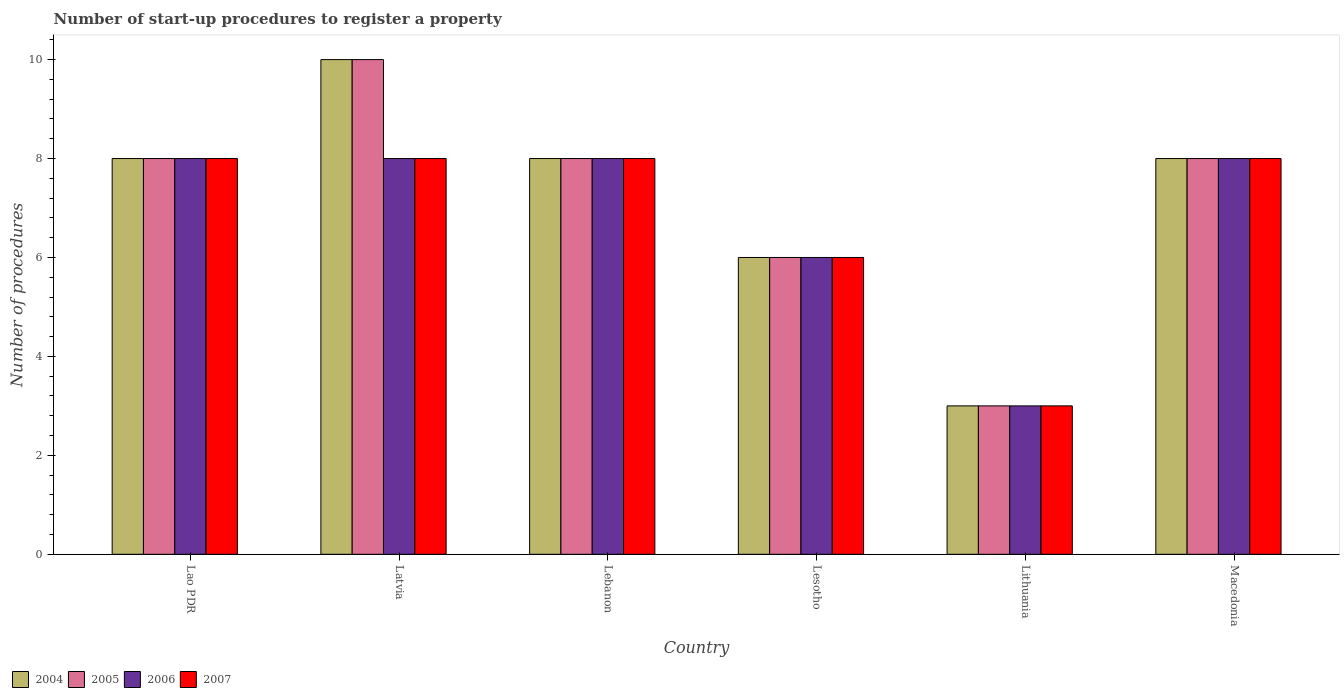How many different coloured bars are there?
Ensure brevity in your answer.  4. Are the number of bars on each tick of the X-axis equal?
Ensure brevity in your answer.  Yes. How many bars are there on the 6th tick from the right?
Your answer should be very brief. 4. What is the label of the 4th group of bars from the left?
Provide a short and direct response. Lesotho. In how many cases, is the number of bars for a given country not equal to the number of legend labels?
Provide a short and direct response. 0. What is the number of procedures required to register a property in 2007 in Lesotho?
Ensure brevity in your answer.  6. In which country was the number of procedures required to register a property in 2006 maximum?
Offer a terse response. Lao PDR. In which country was the number of procedures required to register a property in 2005 minimum?
Offer a very short reply. Lithuania. What is the total number of procedures required to register a property in 2005 in the graph?
Your answer should be very brief. 43. What is the difference between the number of procedures required to register a property in 2006 in Lao PDR and that in Latvia?
Make the answer very short. 0. What is the average number of procedures required to register a property in 2007 per country?
Provide a short and direct response. 6.83. In how many countries, is the number of procedures required to register a property in 2007 greater than 4.8?
Your response must be concise. 5. What is the ratio of the number of procedures required to register a property in 2004 in Lao PDR to that in Lebanon?
Make the answer very short. 1. Is the number of procedures required to register a property in 2007 in Lao PDR less than that in Lesotho?
Provide a short and direct response. No. Is the difference between the number of procedures required to register a property in 2004 in Lesotho and Macedonia greater than the difference between the number of procedures required to register a property in 2006 in Lesotho and Macedonia?
Give a very brief answer. No. What is the difference between the highest and the lowest number of procedures required to register a property in 2005?
Offer a very short reply. 7. Is it the case that in every country, the sum of the number of procedures required to register a property in 2005 and number of procedures required to register a property in 2006 is greater than the sum of number of procedures required to register a property in 2007 and number of procedures required to register a property in 2004?
Your answer should be very brief. No. Is it the case that in every country, the sum of the number of procedures required to register a property in 2005 and number of procedures required to register a property in 2007 is greater than the number of procedures required to register a property in 2004?
Provide a short and direct response. Yes. How many bars are there?
Your answer should be very brief. 24. Are the values on the major ticks of Y-axis written in scientific E-notation?
Offer a very short reply. No. Where does the legend appear in the graph?
Give a very brief answer. Bottom left. What is the title of the graph?
Offer a very short reply. Number of start-up procedures to register a property. Does "2002" appear as one of the legend labels in the graph?
Ensure brevity in your answer.  No. What is the label or title of the Y-axis?
Your response must be concise. Number of procedures. What is the Number of procedures of 2004 in Lao PDR?
Provide a succinct answer. 8. What is the Number of procedures of 2004 in Latvia?
Your answer should be very brief. 10. What is the Number of procedures in 2005 in Latvia?
Ensure brevity in your answer.  10. What is the Number of procedures in 2006 in Lesotho?
Your answer should be compact. 6. What is the Number of procedures of 2007 in Lesotho?
Your response must be concise. 6. What is the Number of procedures in 2004 in Lithuania?
Ensure brevity in your answer.  3. What is the Number of procedures in 2005 in Lithuania?
Your answer should be compact. 3. What is the Number of procedures of 2006 in Lithuania?
Offer a terse response. 3. What is the Number of procedures in 2006 in Macedonia?
Your answer should be compact. 8. Across all countries, what is the maximum Number of procedures of 2004?
Provide a short and direct response. 10. Across all countries, what is the maximum Number of procedures of 2005?
Make the answer very short. 10. Across all countries, what is the minimum Number of procedures of 2005?
Your answer should be compact. 3. Across all countries, what is the minimum Number of procedures in 2006?
Offer a very short reply. 3. Across all countries, what is the minimum Number of procedures of 2007?
Your answer should be very brief. 3. What is the total Number of procedures in 2004 in the graph?
Make the answer very short. 43. What is the total Number of procedures of 2006 in the graph?
Ensure brevity in your answer.  41. What is the total Number of procedures of 2007 in the graph?
Your response must be concise. 41. What is the difference between the Number of procedures of 2004 in Lao PDR and that in Latvia?
Offer a very short reply. -2. What is the difference between the Number of procedures of 2007 in Lao PDR and that in Latvia?
Offer a very short reply. 0. What is the difference between the Number of procedures of 2004 in Lao PDR and that in Lebanon?
Your response must be concise. 0. What is the difference between the Number of procedures of 2006 in Lao PDR and that in Lebanon?
Make the answer very short. 0. What is the difference between the Number of procedures in 2004 in Lao PDR and that in Lesotho?
Give a very brief answer. 2. What is the difference between the Number of procedures in 2005 in Lao PDR and that in Lesotho?
Your answer should be compact. 2. What is the difference between the Number of procedures in 2006 in Lao PDR and that in Lesotho?
Make the answer very short. 2. What is the difference between the Number of procedures of 2007 in Lao PDR and that in Lesotho?
Give a very brief answer. 2. What is the difference between the Number of procedures of 2005 in Lao PDR and that in Lithuania?
Provide a succinct answer. 5. What is the difference between the Number of procedures in 2007 in Lao PDR and that in Lithuania?
Your response must be concise. 5. What is the difference between the Number of procedures in 2005 in Lao PDR and that in Macedonia?
Provide a succinct answer. 0. What is the difference between the Number of procedures of 2006 in Lao PDR and that in Macedonia?
Ensure brevity in your answer.  0. What is the difference between the Number of procedures of 2004 in Latvia and that in Lebanon?
Provide a succinct answer. 2. What is the difference between the Number of procedures in 2005 in Latvia and that in Lesotho?
Your answer should be very brief. 4. What is the difference between the Number of procedures of 2006 in Latvia and that in Lesotho?
Your response must be concise. 2. What is the difference between the Number of procedures of 2007 in Latvia and that in Lesotho?
Provide a succinct answer. 2. What is the difference between the Number of procedures of 2006 in Latvia and that in Lithuania?
Your answer should be very brief. 5. What is the difference between the Number of procedures in 2006 in Latvia and that in Macedonia?
Ensure brevity in your answer.  0. What is the difference between the Number of procedures in 2007 in Latvia and that in Macedonia?
Offer a very short reply. 0. What is the difference between the Number of procedures in 2004 in Lebanon and that in Lesotho?
Ensure brevity in your answer.  2. What is the difference between the Number of procedures of 2005 in Lebanon and that in Lesotho?
Provide a short and direct response. 2. What is the difference between the Number of procedures of 2006 in Lebanon and that in Lesotho?
Your response must be concise. 2. What is the difference between the Number of procedures in 2004 in Lebanon and that in Lithuania?
Your answer should be compact. 5. What is the difference between the Number of procedures of 2005 in Lebanon and that in Lithuania?
Offer a terse response. 5. What is the difference between the Number of procedures of 2006 in Lebanon and that in Lithuania?
Your response must be concise. 5. What is the difference between the Number of procedures of 2006 in Lebanon and that in Macedonia?
Provide a short and direct response. 0. What is the difference between the Number of procedures in 2004 in Lesotho and that in Lithuania?
Make the answer very short. 3. What is the difference between the Number of procedures of 2005 in Lesotho and that in Lithuania?
Your response must be concise. 3. What is the difference between the Number of procedures of 2006 in Lesotho and that in Lithuania?
Make the answer very short. 3. What is the difference between the Number of procedures in 2007 in Lesotho and that in Lithuania?
Give a very brief answer. 3. What is the difference between the Number of procedures in 2005 in Lesotho and that in Macedonia?
Ensure brevity in your answer.  -2. What is the difference between the Number of procedures of 2006 in Lesotho and that in Macedonia?
Offer a terse response. -2. What is the difference between the Number of procedures of 2004 in Lithuania and that in Macedonia?
Offer a terse response. -5. What is the difference between the Number of procedures in 2004 in Lao PDR and the Number of procedures in 2006 in Latvia?
Provide a short and direct response. 0. What is the difference between the Number of procedures in 2005 in Lao PDR and the Number of procedures in 2007 in Latvia?
Provide a succinct answer. 0. What is the difference between the Number of procedures in 2006 in Lao PDR and the Number of procedures in 2007 in Latvia?
Give a very brief answer. 0. What is the difference between the Number of procedures of 2004 in Lao PDR and the Number of procedures of 2005 in Lebanon?
Your response must be concise. 0. What is the difference between the Number of procedures of 2004 in Lao PDR and the Number of procedures of 2007 in Lebanon?
Your answer should be very brief. 0. What is the difference between the Number of procedures in 2005 in Lao PDR and the Number of procedures in 2006 in Lebanon?
Keep it short and to the point. 0. What is the difference between the Number of procedures in 2004 in Lao PDR and the Number of procedures in 2005 in Lesotho?
Offer a terse response. 2. What is the difference between the Number of procedures in 2004 in Lao PDR and the Number of procedures in 2007 in Lesotho?
Ensure brevity in your answer.  2. What is the difference between the Number of procedures in 2005 in Lao PDR and the Number of procedures in 2006 in Lesotho?
Provide a short and direct response. 2. What is the difference between the Number of procedures in 2006 in Lao PDR and the Number of procedures in 2007 in Lesotho?
Keep it short and to the point. 2. What is the difference between the Number of procedures of 2004 in Lao PDR and the Number of procedures of 2007 in Lithuania?
Provide a short and direct response. 5. What is the difference between the Number of procedures in 2005 in Lao PDR and the Number of procedures in 2006 in Lithuania?
Make the answer very short. 5. What is the difference between the Number of procedures of 2006 in Lao PDR and the Number of procedures of 2007 in Lithuania?
Ensure brevity in your answer.  5. What is the difference between the Number of procedures of 2004 in Lao PDR and the Number of procedures of 2006 in Macedonia?
Your response must be concise. 0. What is the difference between the Number of procedures of 2005 in Lao PDR and the Number of procedures of 2006 in Macedonia?
Give a very brief answer. 0. What is the difference between the Number of procedures of 2004 in Latvia and the Number of procedures of 2005 in Lebanon?
Offer a terse response. 2. What is the difference between the Number of procedures of 2005 in Latvia and the Number of procedures of 2006 in Lebanon?
Offer a very short reply. 2. What is the difference between the Number of procedures of 2005 in Latvia and the Number of procedures of 2007 in Lesotho?
Your answer should be compact. 4. What is the difference between the Number of procedures in 2004 in Latvia and the Number of procedures in 2005 in Lithuania?
Give a very brief answer. 7. What is the difference between the Number of procedures in 2004 in Latvia and the Number of procedures in 2006 in Lithuania?
Your answer should be very brief. 7. What is the difference between the Number of procedures in 2004 in Latvia and the Number of procedures in 2007 in Lithuania?
Offer a very short reply. 7. What is the difference between the Number of procedures in 2005 in Latvia and the Number of procedures in 2006 in Lithuania?
Your response must be concise. 7. What is the difference between the Number of procedures of 2004 in Latvia and the Number of procedures of 2005 in Macedonia?
Your answer should be very brief. 2. What is the difference between the Number of procedures in 2004 in Latvia and the Number of procedures in 2007 in Macedonia?
Your answer should be compact. 2. What is the difference between the Number of procedures of 2004 in Lebanon and the Number of procedures of 2005 in Lesotho?
Make the answer very short. 2. What is the difference between the Number of procedures of 2005 in Lebanon and the Number of procedures of 2006 in Lesotho?
Ensure brevity in your answer.  2. What is the difference between the Number of procedures in 2005 in Lebanon and the Number of procedures in 2007 in Lesotho?
Your answer should be compact. 2. What is the difference between the Number of procedures in 2004 in Lebanon and the Number of procedures in 2005 in Lithuania?
Ensure brevity in your answer.  5. What is the difference between the Number of procedures in 2004 in Lebanon and the Number of procedures in 2007 in Lithuania?
Make the answer very short. 5. What is the difference between the Number of procedures in 2004 in Lebanon and the Number of procedures in 2005 in Macedonia?
Provide a short and direct response. 0. What is the difference between the Number of procedures of 2004 in Lebanon and the Number of procedures of 2006 in Macedonia?
Ensure brevity in your answer.  0. What is the difference between the Number of procedures in 2004 in Lebanon and the Number of procedures in 2007 in Macedonia?
Provide a succinct answer. 0. What is the difference between the Number of procedures in 2005 in Lebanon and the Number of procedures in 2006 in Macedonia?
Provide a short and direct response. 0. What is the difference between the Number of procedures of 2004 in Lesotho and the Number of procedures of 2007 in Lithuania?
Ensure brevity in your answer.  3. What is the difference between the Number of procedures in 2005 in Lesotho and the Number of procedures in 2007 in Lithuania?
Provide a short and direct response. 3. What is the difference between the Number of procedures in 2006 in Lesotho and the Number of procedures in 2007 in Lithuania?
Make the answer very short. 3. What is the difference between the Number of procedures of 2004 in Lesotho and the Number of procedures of 2007 in Macedonia?
Your answer should be compact. -2. What is the average Number of procedures of 2004 per country?
Provide a succinct answer. 7.17. What is the average Number of procedures in 2005 per country?
Your answer should be compact. 7.17. What is the average Number of procedures in 2006 per country?
Provide a short and direct response. 6.83. What is the average Number of procedures of 2007 per country?
Offer a very short reply. 6.83. What is the difference between the Number of procedures in 2004 and Number of procedures in 2007 in Lao PDR?
Offer a terse response. 0. What is the difference between the Number of procedures of 2005 and Number of procedures of 2006 in Lao PDR?
Offer a very short reply. 0. What is the difference between the Number of procedures in 2006 and Number of procedures in 2007 in Lao PDR?
Give a very brief answer. 0. What is the difference between the Number of procedures of 2004 and Number of procedures of 2006 in Latvia?
Ensure brevity in your answer.  2. What is the difference between the Number of procedures in 2005 and Number of procedures in 2007 in Latvia?
Give a very brief answer. 2. What is the difference between the Number of procedures in 2004 and Number of procedures in 2007 in Lebanon?
Offer a very short reply. 0. What is the difference between the Number of procedures of 2004 and Number of procedures of 2005 in Lesotho?
Ensure brevity in your answer.  0. What is the difference between the Number of procedures of 2005 and Number of procedures of 2006 in Lesotho?
Provide a short and direct response. 0. What is the difference between the Number of procedures in 2006 and Number of procedures in 2007 in Lesotho?
Provide a short and direct response. 0. What is the difference between the Number of procedures of 2004 and Number of procedures of 2005 in Lithuania?
Offer a very short reply. 0. What is the difference between the Number of procedures of 2004 and Number of procedures of 2006 in Lithuania?
Ensure brevity in your answer.  0. What is the difference between the Number of procedures in 2004 and Number of procedures in 2007 in Lithuania?
Keep it short and to the point. 0. What is the difference between the Number of procedures in 2005 and Number of procedures in 2006 in Lithuania?
Your answer should be very brief. 0. What is the difference between the Number of procedures of 2005 and Number of procedures of 2007 in Lithuania?
Make the answer very short. 0. What is the difference between the Number of procedures of 2006 and Number of procedures of 2007 in Lithuania?
Your answer should be compact. 0. What is the difference between the Number of procedures of 2004 and Number of procedures of 2005 in Macedonia?
Your answer should be compact. 0. What is the difference between the Number of procedures of 2005 and Number of procedures of 2006 in Macedonia?
Offer a very short reply. 0. What is the difference between the Number of procedures in 2006 and Number of procedures in 2007 in Macedonia?
Keep it short and to the point. 0. What is the ratio of the Number of procedures in 2005 in Lao PDR to that in Latvia?
Make the answer very short. 0.8. What is the ratio of the Number of procedures in 2007 in Lao PDR to that in Latvia?
Your answer should be compact. 1. What is the ratio of the Number of procedures in 2005 in Lao PDR to that in Lebanon?
Ensure brevity in your answer.  1. What is the ratio of the Number of procedures in 2006 in Lao PDR to that in Lebanon?
Keep it short and to the point. 1. What is the ratio of the Number of procedures of 2007 in Lao PDR to that in Lebanon?
Keep it short and to the point. 1. What is the ratio of the Number of procedures in 2004 in Lao PDR to that in Lithuania?
Give a very brief answer. 2.67. What is the ratio of the Number of procedures of 2005 in Lao PDR to that in Lithuania?
Offer a terse response. 2.67. What is the ratio of the Number of procedures in 2006 in Lao PDR to that in Lithuania?
Your answer should be very brief. 2.67. What is the ratio of the Number of procedures in 2007 in Lao PDR to that in Lithuania?
Your response must be concise. 2.67. What is the ratio of the Number of procedures in 2004 in Lao PDR to that in Macedonia?
Your answer should be compact. 1. What is the ratio of the Number of procedures of 2006 in Lao PDR to that in Macedonia?
Your answer should be compact. 1. What is the ratio of the Number of procedures in 2004 in Latvia to that in Lebanon?
Make the answer very short. 1.25. What is the ratio of the Number of procedures in 2004 in Latvia to that in Lesotho?
Your response must be concise. 1.67. What is the ratio of the Number of procedures in 2006 in Latvia to that in Lesotho?
Make the answer very short. 1.33. What is the ratio of the Number of procedures of 2007 in Latvia to that in Lesotho?
Make the answer very short. 1.33. What is the ratio of the Number of procedures of 2004 in Latvia to that in Lithuania?
Keep it short and to the point. 3.33. What is the ratio of the Number of procedures of 2005 in Latvia to that in Lithuania?
Your response must be concise. 3.33. What is the ratio of the Number of procedures of 2006 in Latvia to that in Lithuania?
Offer a very short reply. 2.67. What is the ratio of the Number of procedures in 2007 in Latvia to that in Lithuania?
Your answer should be very brief. 2.67. What is the ratio of the Number of procedures of 2006 in Latvia to that in Macedonia?
Provide a short and direct response. 1. What is the ratio of the Number of procedures in 2004 in Lebanon to that in Lesotho?
Keep it short and to the point. 1.33. What is the ratio of the Number of procedures of 2005 in Lebanon to that in Lesotho?
Make the answer very short. 1.33. What is the ratio of the Number of procedures in 2004 in Lebanon to that in Lithuania?
Your response must be concise. 2.67. What is the ratio of the Number of procedures of 2005 in Lebanon to that in Lithuania?
Your response must be concise. 2.67. What is the ratio of the Number of procedures in 2006 in Lebanon to that in Lithuania?
Offer a very short reply. 2.67. What is the ratio of the Number of procedures in 2007 in Lebanon to that in Lithuania?
Your answer should be very brief. 2.67. What is the ratio of the Number of procedures of 2004 in Lebanon to that in Macedonia?
Offer a very short reply. 1. What is the ratio of the Number of procedures of 2005 in Lebanon to that in Macedonia?
Provide a short and direct response. 1. What is the ratio of the Number of procedures in 2007 in Lebanon to that in Macedonia?
Your answer should be very brief. 1. What is the ratio of the Number of procedures in 2004 in Lesotho to that in Lithuania?
Give a very brief answer. 2. What is the ratio of the Number of procedures of 2006 in Lesotho to that in Lithuania?
Your response must be concise. 2. What is the ratio of the Number of procedures of 2007 in Lesotho to that in Macedonia?
Ensure brevity in your answer.  0.75. What is the ratio of the Number of procedures in 2006 in Lithuania to that in Macedonia?
Make the answer very short. 0.38. What is the ratio of the Number of procedures in 2007 in Lithuania to that in Macedonia?
Give a very brief answer. 0.38. What is the difference between the highest and the second highest Number of procedures in 2004?
Ensure brevity in your answer.  2. What is the difference between the highest and the second highest Number of procedures in 2007?
Offer a very short reply. 0. What is the difference between the highest and the lowest Number of procedures in 2004?
Give a very brief answer. 7. What is the difference between the highest and the lowest Number of procedures of 2007?
Offer a terse response. 5. 